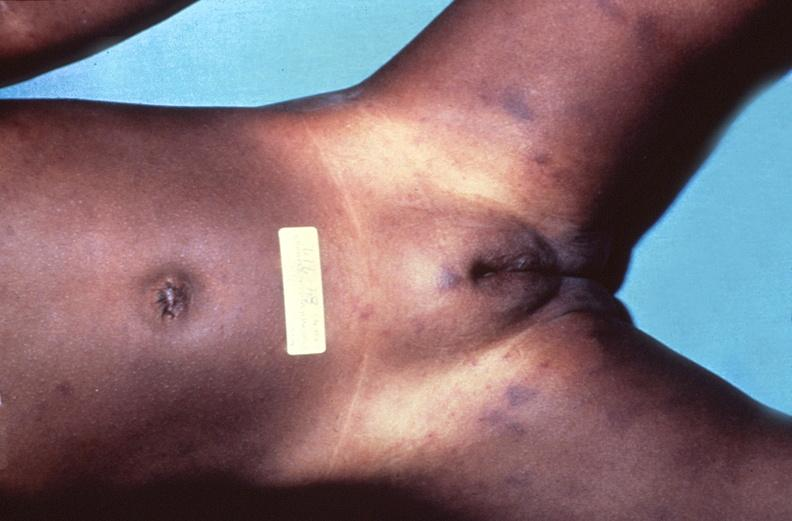does this image show meningococcemia, petechia?
Answer the question using a single word or phrase. Yes 